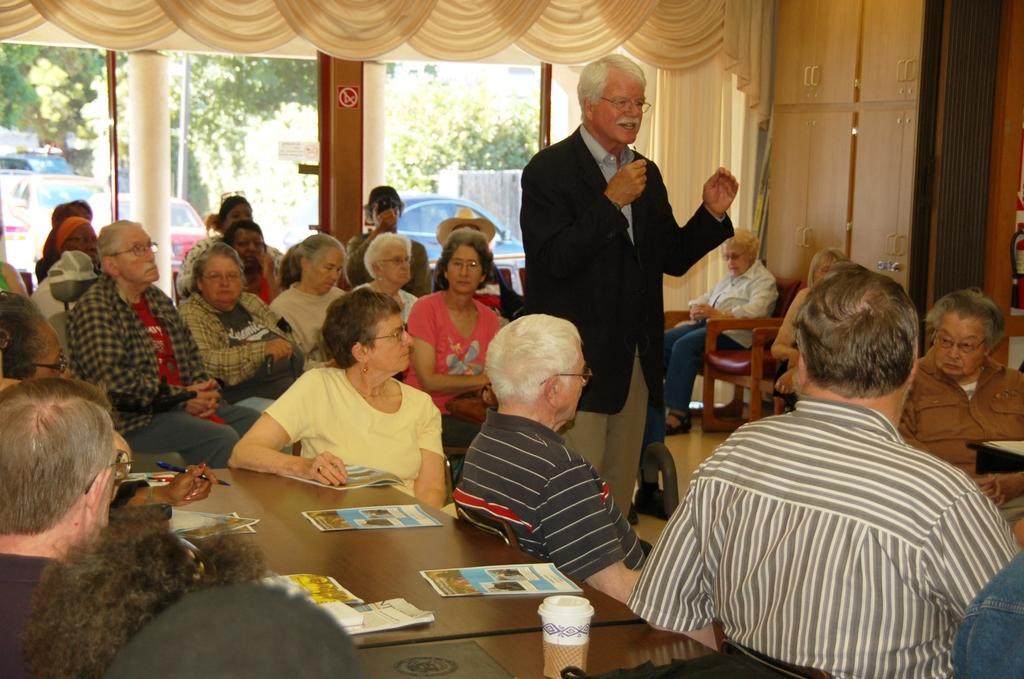In one or two sentences, can you explain what this image depicts? There is a person standing and talking in the middle of the people who are gathered. On the left hand side, there are people sitting. In front of them, there is a table. Books, glass and some other materials on it. In the background, there is a glass window, trees, cars, curtain, and some persons sitting. 